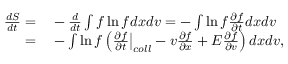<formula> <loc_0><loc_0><loc_500><loc_500>\begin{array} { r l } { \frac { d S } { d t } = } & - \frac { d } { d t } \int f \ln f d x d v = - \int \ln f \frac { \partial f } { \partial t } d x d v } \\ { = } & - \int \ln f \left ( \frac { \partial f } { \partial t } \Big | _ { c o l l } - v \frac { \partial f } { \partial x } + E \frac { \partial f } { \partial v } \right ) d x d v , } \end{array}</formula> 